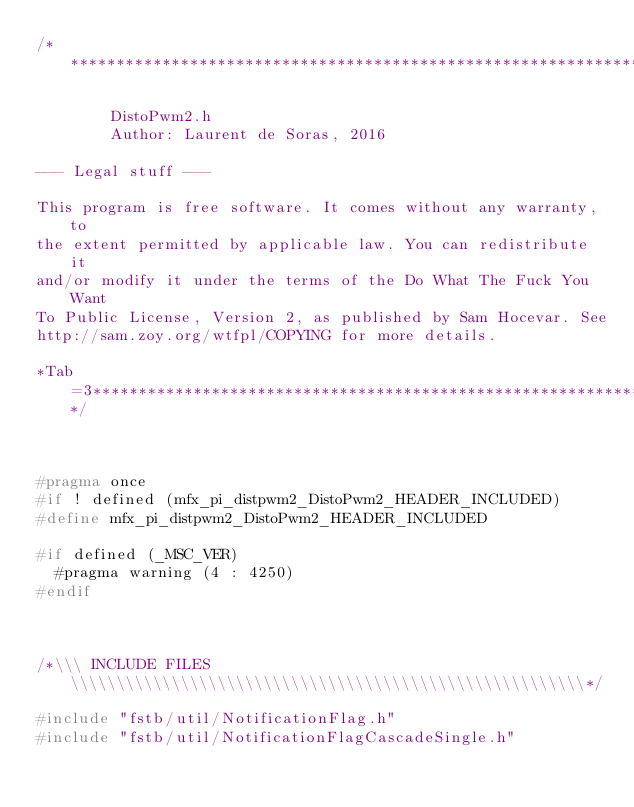Convert code to text. <code><loc_0><loc_0><loc_500><loc_500><_C_>/*****************************************************************************

        DistoPwm2.h
        Author: Laurent de Soras, 2016

--- Legal stuff ---

This program is free software. It comes without any warranty, to
the extent permitted by applicable law. You can redistribute it
and/or modify it under the terms of the Do What The Fuck You Want
To Public License, Version 2, as published by Sam Hocevar. See
http://sam.zoy.org/wtfpl/COPYING for more details.

*Tab=3***********************************************************************/



#pragma once
#if ! defined (mfx_pi_distpwm2_DistoPwm2_HEADER_INCLUDED)
#define mfx_pi_distpwm2_DistoPwm2_HEADER_INCLUDED

#if defined (_MSC_VER)
	#pragma warning (4 : 4250)
#endif



/*\\\ INCLUDE FILES \\\\\\\\\\\\\\\\\\\\\\\\\\\\\\\\\\\\\\\\\\\\\\\\\\\\\\\\*/

#include "fstb/util/NotificationFlag.h"
#include "fstb/util/NotificationFlagCascadeSingle.h"</code> 